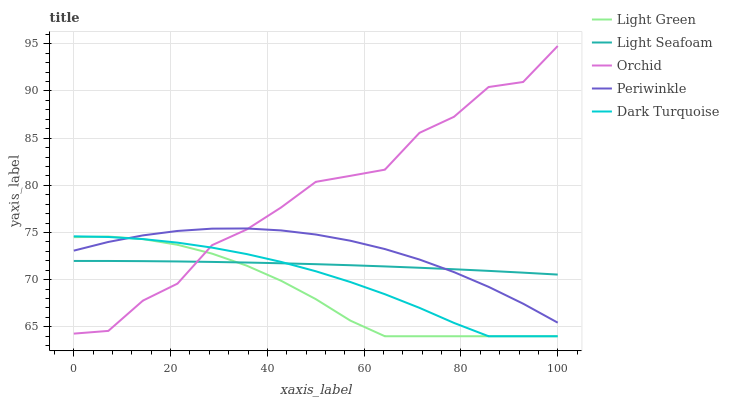Does Light Green have the minimum area under the curve?
Answer yes or no. Yes. Does Orchid have the maximum area under the curve?
Answer yes or no. Yes. Does Light Seafoam have the minimum area under the curve?
Answer yes or no. No. Does Light Seafoam have the maximum area under the curve?
Answer yes or no. No. Is Light Seafoam the smoothest?
Answer yes or no. Yes. Is Orchid the roughest?
Answer yes or no. Yes. Is Periwinkle the smoothest?
Answer yes or no. No. Is Periwinkle the roughest?
Answer yes or no. No. Does Dark Turquoise have the lowest value?
Answer yes or no. Yes. Does Periwinkle have the lowest value?
Answer yes or no. No. Does Orchid have the highest value?
Answer yes or no. Yes. Does Periwinkle have the highest value?
Answer yes or no. No. Does Periwinkle intersect Orchid?
Answer yes or no. Yes. Is Periwinkle less than Orchid?
Answer yes or no. No. Is Periwinkle greater than Orchid?
Answer yes or no. No. 